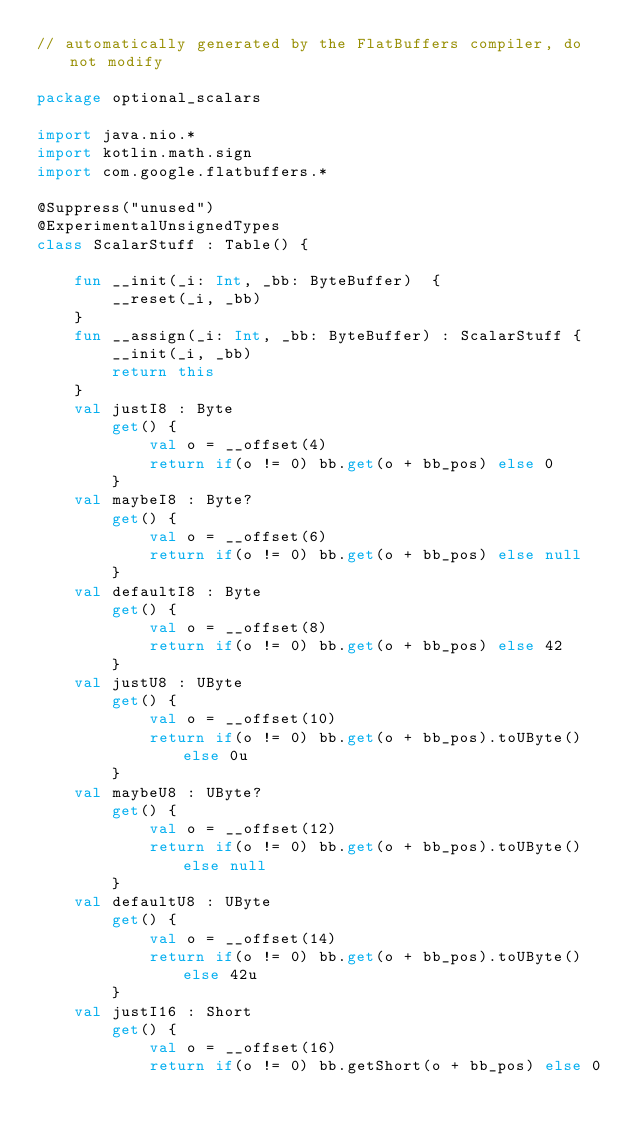Convert code to text. <code><loc_0><loc_0><loc_500><loc_500><_Kotlin_>// automatically generated by the FlatBuffers compiler, do not modify

package optional_scalars

import java.nio.*
import kotlin.math.sign
import com.google.flatbuffers.*

@Suppress("unused")
@ExperimentalUnsignedTypes
class ScalarStuff : Table() {

    fun __init(_i: Int, _bb: ByteBuffer)  {
        __reset(_i, _bb)
    }
    fun __assign(_i: Int, _bb: ByteBuffer) : ScalarStuff {
        __init(_i, _bb)
        return this
    }
    val justI8 : Byte
        get() {
            val o = __offset(4)
            return if(o != 0) bb.get(o + bb_pos) else 0
        }
    val maybeI8 : Byte?
        get() {
            val o = __offset(6)
            return if(o != 0) bb.get(o + bb_pos) else null
        }
    val defaultI8 : Byte
        get() {
            val o = __offset(8)
            return if(o != 0) bb.get(o + bb_pos) else 42
        }
    val justU8 : UByte
        get() {
            val o = __offset(10)
            return if(o != 0) bb.get(o + bb_pos).toUByte() else 0u
        }
    val maybeU8 : UByte?
        get() {
            val o = __offset(12)
            return if(o != 0) bb.get(o + bb_pos).toUByte() else null
        }
    val defaultU8 : UByte
        get() {
            val o = __offset(14)
            return if(o != 0) bb.get(o + bb_pos).toUByte() else 42u
        }
    val justI16 : Short
        get() {
            val o = __offset(16)
            return if(o != 0) bb.getShort(o + bb_pos) else 0</code> 